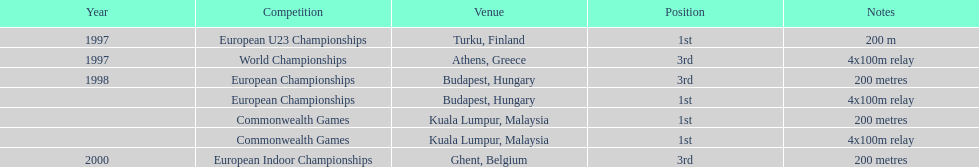How many events were won in malaysia? 2. Can you parse all the data within this table? {'header': ['Year', 'Competition', 'Venue', 'Position', 'Notes'], 'rows': [['1997', 'European U23 Championships', 'Turku, Finland', '1st', '200 m'], ['1997', 'World Championships', 'Athens, Greece', '3rd', '4x100m relay'], ['1998', 'European Championships', 'Budapest, Hungary', '3rd', '200 metres'], ['', 'European Championships', 'Budapest, Hungary', '1st', '4x100m relay'], ['', 'Commonwealth Games', 'Kuala Lumpur, Malaysia', '1st', '200 metres'], ['', 'Commonwealth Games', 'Kuala Lumpur, Malaysia', '1st', '4x100m relay'], ['2000', 'European Indoor Championships', 'Ghent, Belgium', '3rd', '200 metres']]} 